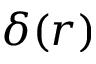Convert formula to latex. <formula><loc_0><loc_0><loc_500><loc_500>\delta ( r )</formula> 